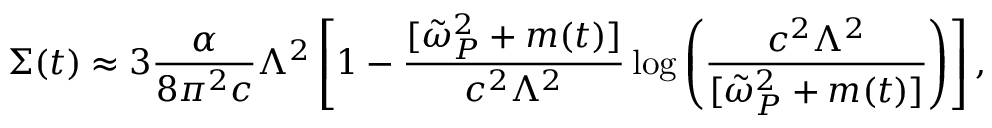Convert formula to latex. <formula><loc_0><loc_0><loc_500><loc_500>\Sigma ( t ) \approx { 3 } \frac { \alpha } { { 8 } \pi ^ { 2 } c } \Lambda ^ { 2 } \left [ 1 - \frac { [ \tilde { \omega } _ { P } ^ { 2 } + m ( t ) ] } { c ^ { 2 } \Lambda ^ { 2 } } \log \left ( \frac { c ^ { 2 } \Lambda ^ { 2 } } { [ \tilde { \omega } _ { P } ^ { 2 } + m ( t ) ] } \right ) \right ] ,</formula> 